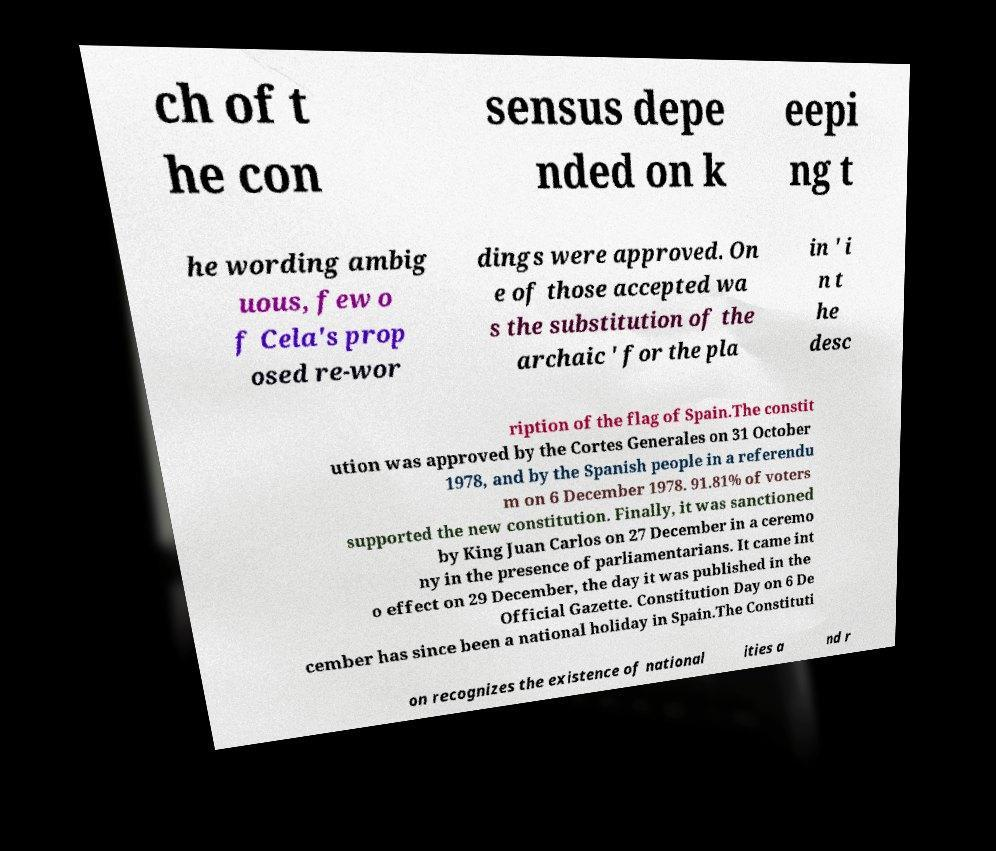Please identify and transcribe the text found in this image. ch of t he con sensus depe nded on k eepi ng t he wording ambig uous, few o f Cela's prop osed re-wor dings were approved. On e of those accepted wa s the substitution of the archaic ' for the pla in ' i n t he desc ription of the flag of Spain.The constit ution was approved by the Cortes Generales on 31 October 1978, and by the Spanish people in a referendu m on 6 December 1978. 91.81% of voters supported the new constitution. Finally, it was sanctioned by King Juan Carlos on 27 December in a ceremo ny in the presence of parliamentarians. It came int o effect on 29 December, the day it was published in the Official Gazette. Constitution Day on 6 De cember has since been a national holiday in Spain.The Constituti on recognizes the existence of national ities a nd r 